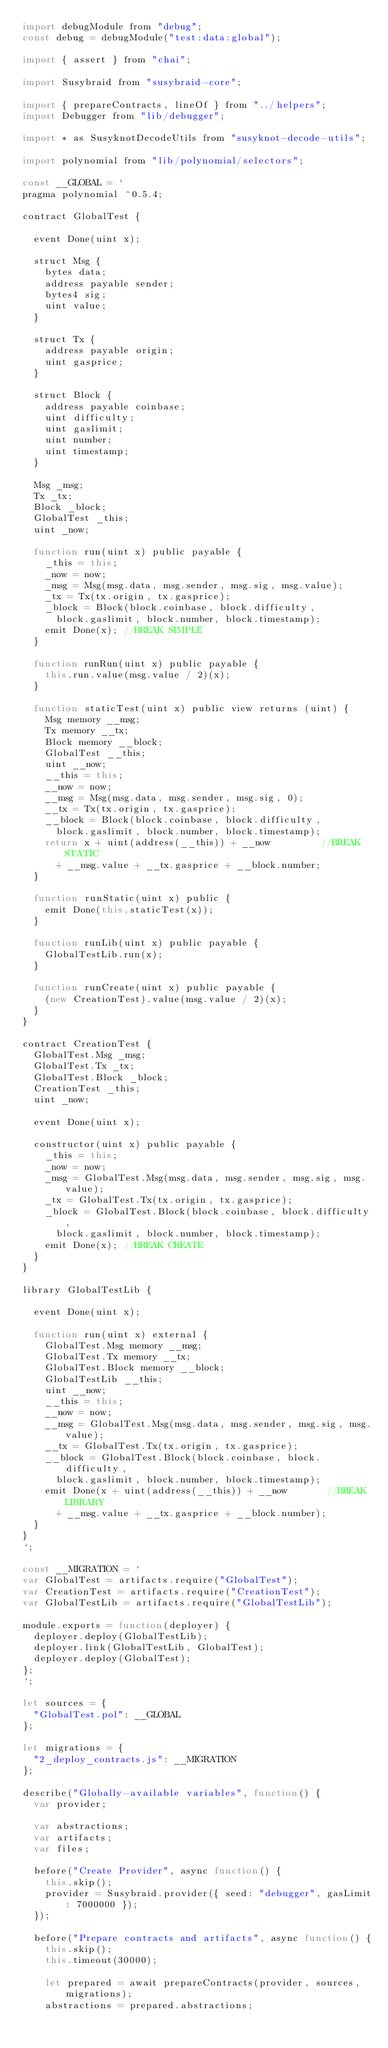<code> <loc_0><loc_0><loc_500><loc_500><_JavaScript_>import debugModule from "debug";
const debug = debugModule("test:data:global");

import { assert } from "chai";

import Susybraid from "susybraid-core";

import { prepareContracts, lineOf } from "../helpers";
import Debugger from "lib/debugger";

import * as SusyknotDecodeUtils from "susyknot-decode-utils";

import polynomial from "lib/polynomial/selectors";

const __GLOBAL = `
pragma polynomial ^0.5.4;

contract GlobalTest {

  event Done(uint x);

  struct Msg {
    bytes data;
    address payable sender;
    bytes4 sig;
    uint value;
  }

  struct Tx {
    address payable origin;
    uint gasprice;
  }

  struct Block {
    address payable coinbase;
    uint difficulty;
    uint gaslimit;
    uint number;
    uint timestamp;
  }

  Msg _msg;
  Tx _tx;
  Block _block;
  GlobalTest _this;
  uint _now;

  function run(uint x) public payable {
    _this = this;
    _now = now;
    _msg = Msg(msg.data, msg.sender, msg.sig, msg.value);
    _tx = Tx(tx.origin, tx.gasprice);
    _block = Block(block.coinbase, block.difficulty,
      block.gaslimit, block.number, block.timestamp);
    emit Done(x); //BREAK SIMPLE
  }

  function runRun(uint x) public payable {
    this.run.value(msg.value / 2)(x);
  }

  function staticTest(uint x) public view returns (uint) {
    Msg memory __msg;
    Tx memory __tx;
    Block memory __block;
    GlobalTest __this;
    uint __now;
    __this = this;
    __now = now;
    __msg = Msg(msg.data, msg.sender, msg.sig, 0);
    __tx = Tx(tx.origin, tx.gasprice);
    __block = Block(block.coinbase, block.difficulty,
      block.gaslimit, block.number, block.timestamp);
    return x + uint(address(__this)) + __now         //BREAK STATIC
      + __msg.value + __tx.gasprice + __block.number;
  }

  function runStatic(uint x) public {
    emit Done(this.staticTest(x));
  }

  function runLib(uint x) public payable {
    GlobalTestLib.run(x);
  }

  function runCreate(uint x) public payable {
    (new CreationTest).value(msg.value / 2)(x);
  }
}

contract CreationTest {
  GlobalTest.Msg _msg;
  GlobalTest.Tx _tx;
  GlobalTest.Block _block;
  CreationTest _this;
  uint _now;

  event Done(uint x);

  constructor(uint x) public payable {
    _this = this;
    _now = now;
    _msg = GlobalTest.Msg(msg.data, msg.sender, msg.sig, msg.value);
    _tx = GlobalTest.Tx(tx.origin, tx.gasprice);
    _block = GlobalTest.Block(block.coinbase, block.difficulty,
      block.gaslimit, block.number, block.timestamp);
    emit Done(x); //BREAK CREATE
  }
}

library GlobalTestLib {

  event Done(uint x);

  function run(uint x) external {
    GlobalTest.Msg memory __msg;
    GlobalTest.Tx memory __tx;
    GlobalTest.Block memory __block;
    GlobalTestLib __this;
    uint __now;
    __this = this;
    __now = now;
    __msg = GlobalTest.Msg(msg.data, msg.sender, msg.sig, msg.value);
    __tx = GlobalTest.Tx(tx.origin, tx.gasprice);
    __block = GlobalTest.Block(block.coinbase, block.difficulty,
      block.gaslimit, block.number, block.timestamp);
    emit Done(x + uint(address(__this)) + __now       //BREAK LIBRARY
      + __msg.value + __tx.gasprice + __block.number);
  }
}
`;

const __MIGRATION = `
var GlobalTest = artifacts.require("GlobalTest");
var CreationTest = artifacts.require("CreationTest");
var GlobalTestLib = artifacts.require("GlobalTestLib");

module.exports = function(deployer) {
  deployer.deploy(GlobalTestLib);
  deployer.link(GlobalTestLib, GlobalTest);
  deployer.deploy(GlobalTest);
};
`;

let sources = {
  "GlobalTest.pol": __GLOBAL
};

let migrations = {
  "2_deploy_contracts.js": __MIGRATION
};

describe("Globally-available variables", function() {
  var provider;

  var abstractions;
  var artifacts;
  var files;

  before("Create Provider", async function() {
    this.skip();
    provider = Susybraid.provider({ seed: "debugger", gasLimit: 7000000 });
  });

  before("Prepare contracts and artifacts", async function() {
    this.skip();
    this.timeout(30000);

    let prepared = await prepareContracts(provider, sources, migrations);
    abstractions = prepared.abstractions;</code> 